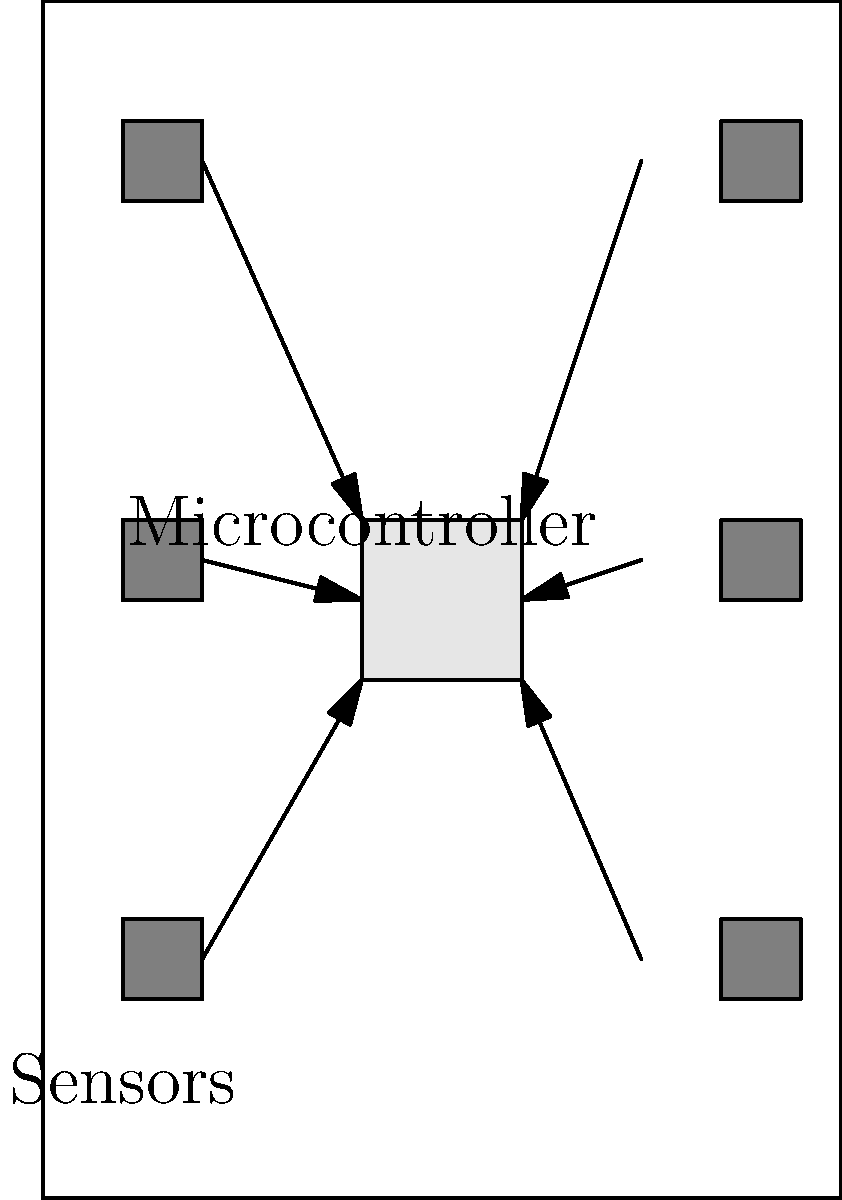In the given circuit layout for integrating sensors into a refrigerator, how many sensors are connected to the microcontroller, and what topology does this connection represent? Explain why this topology is advantageous for a refrigerator application. To answer this question, let's analyze the circuit layout step-by-step:

1. Count the number of sensors:
   There are 6 small squares in the diagram, representing sensors. They are placed at various positions within the refrigerator outline.

2. Identify the microcontroller:
   The larger rectangle in the center represents the microcontroller.

3. Observe the connections:
   Each sensor has an arrow pointing towards the microcontroller, indicating a direct connection.

4. Determine the topology:
   This layout represents a star topology. In a star topology, each node (sensor) is directly connected to a central hub (microcontroller).

5. Advantages of star topology for a refrigerator application:
   a) Centralized control: The microcontroller can easily manage and process data from all sensors.
   b) Fault isolation: If one sensor fails, it doesn't affect the others.
   c) Easy to add or remove sensors: Modular design allows for simple upgrades or maintenance.
   d) Reduced wiring complexity: Each sensor only needs one connection to the microcontroller.
   e) Low latency: Direct connections ensure quick data transmission from sensors to the microcontroller.

These advantages are particularly beneficial for a refrigerator, where:
- Multiple areas need monitoring (e.g., freezer, main compartment, door)
- Quick response to temperature changes is crucial
- Future upgrades (e.g., adding new sensors) should be straightforward
- Reliability is important for food safety
Answer: 6 sensors, star topology 